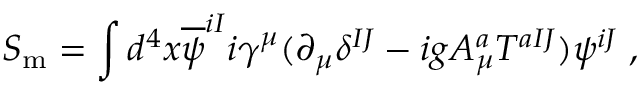<formula> <loc_0><loc_0><loc_500><loc_500>S _ { m } = \int d ^ { 4 } x \overline { \psi } ^ { i I } i \gamma ^ { \mu } ( \partial _ { \mu } \delta ^ { I J } - i g A _ { \mu } ^ { a } T ^ { a I J } ) \psi ^ { i J } \, ,</formula> 